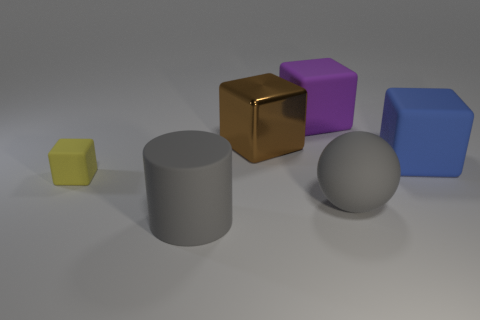Subtract all small yellow rubber blocks. How many blocks are left? 3 Add 2 small gray rubber things. How many objects exist? 8 Subtract all brown blocks. How many blocks are left? 3 Add 4 yellow rubber objects. How many yellow rubber objects are left? 5 Add 6 large gray cylinders. How many large gray cylinders exist? 7 Subtract 0 green balls. How many objects are left? 6 Subtract all cylinders. How many objects are left? 5 Subtract 1 blocks. How many blocks are left? 3 Subtract all green blocks. Subtract all green cylinders. How many blocks are left? 4 Subtract all brown cubes. Subtract all big gray metal cylinders. How many objects are left? 5 